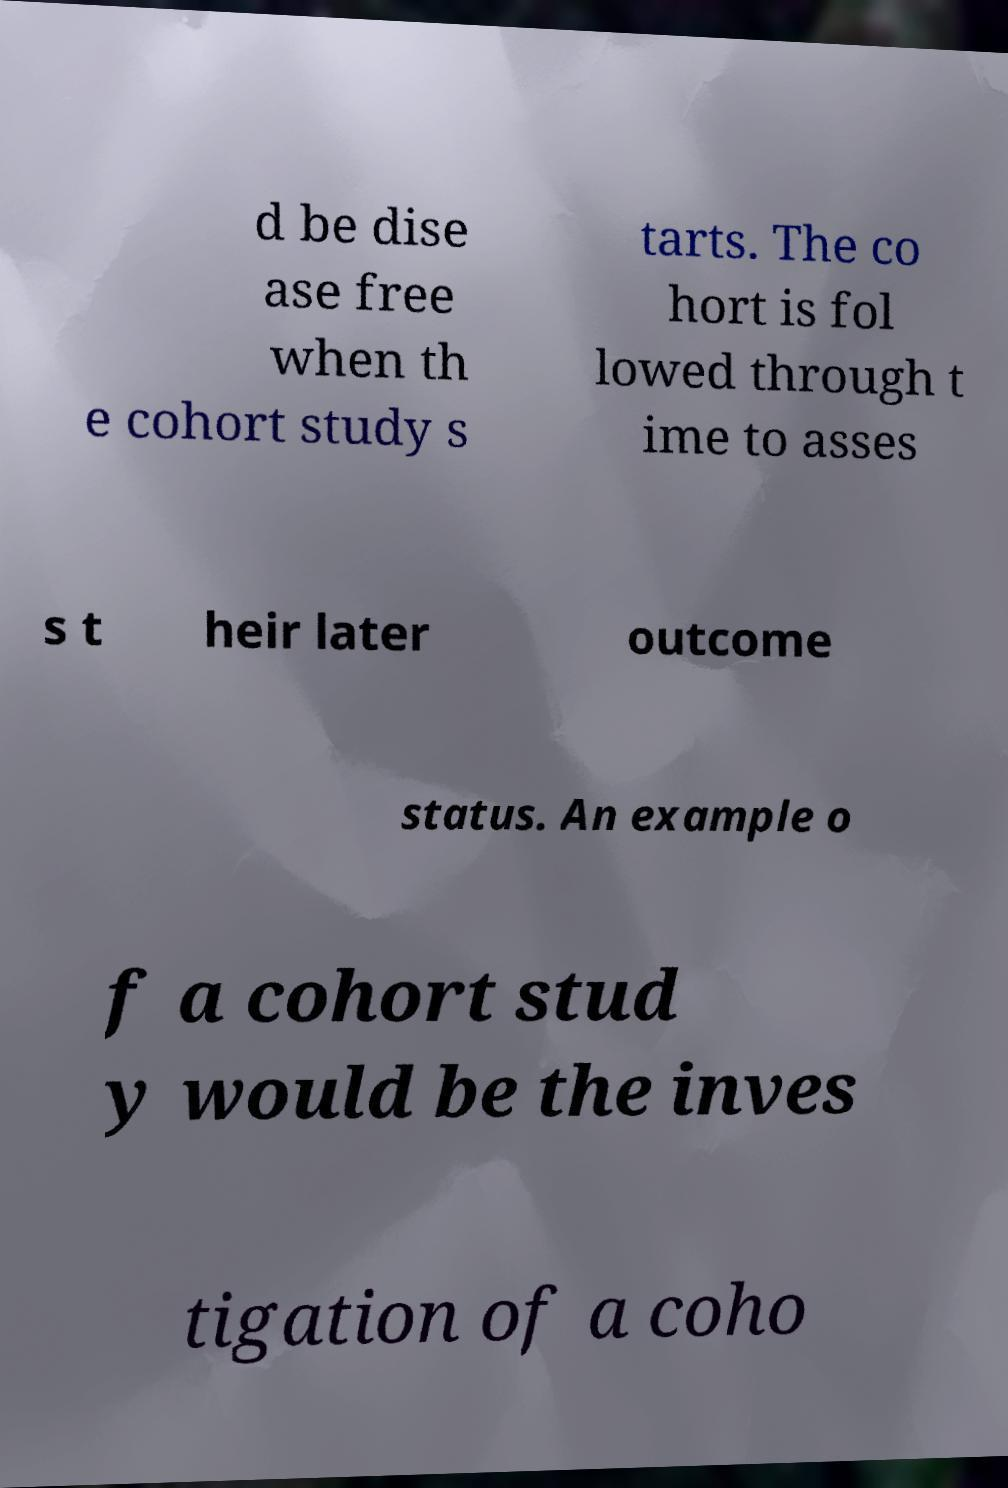What messages or text are displayed in this image? I need them in a readable, typed format. d be dise ase free when th e cohort study s tarts. The co hort is fol lowed through t ime to asses s t heir later outcome status. An example o f a cohort stud y would be the inves tigation of a coho 